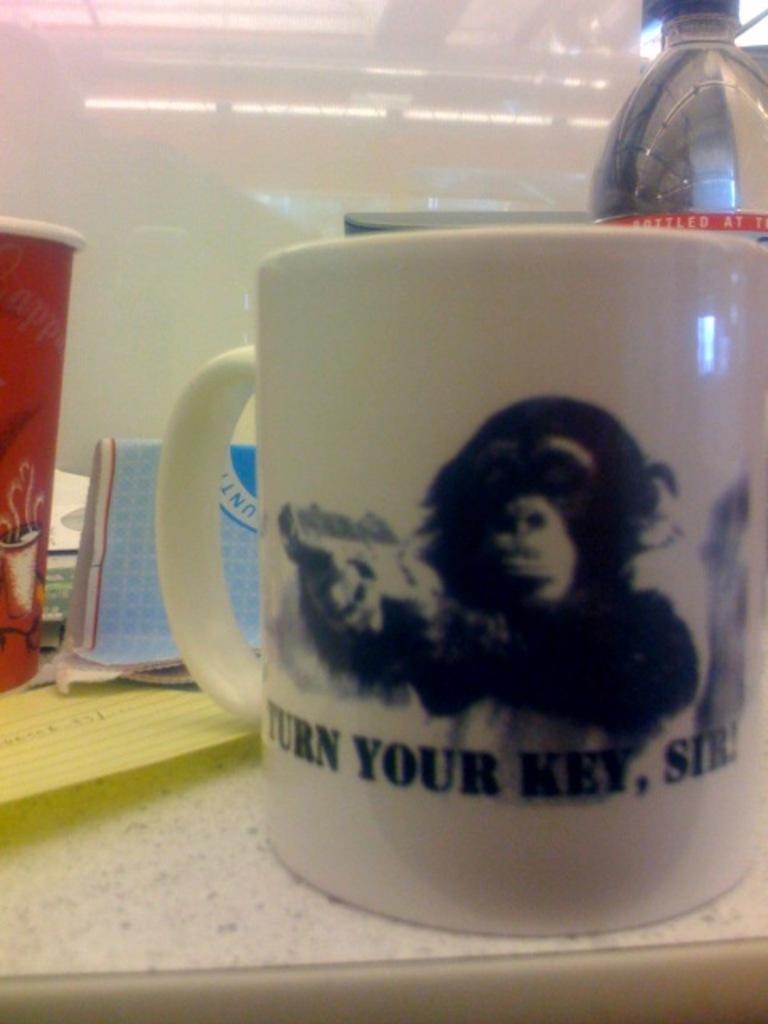What is the quote on this mug?
Ensure brevity in your answer.  Turn your key, sir. 